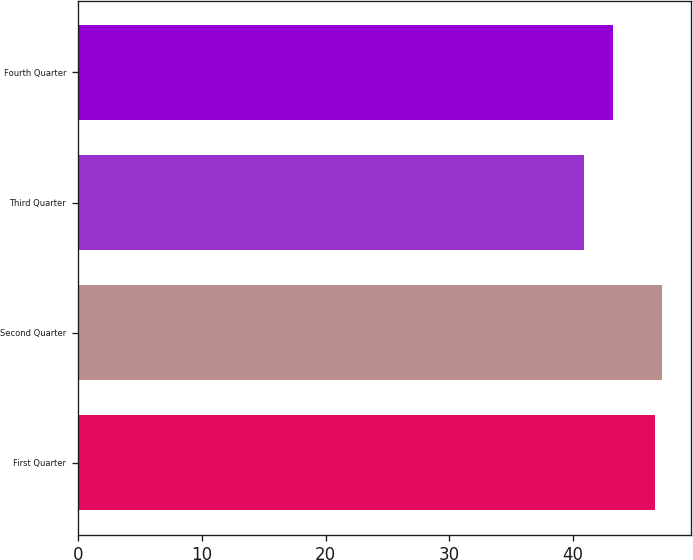<chart> <loc_0><loc_0><loc_500><loc_500><bar_chart><fcel>First Quarter<fcel>Second Quarter<fcel>Third Quarter<fcel>Fourth Quarter<nl><fcel>46.58<fcel>47.19<fcel>40.88<fcel>43.2<nl></chart> 